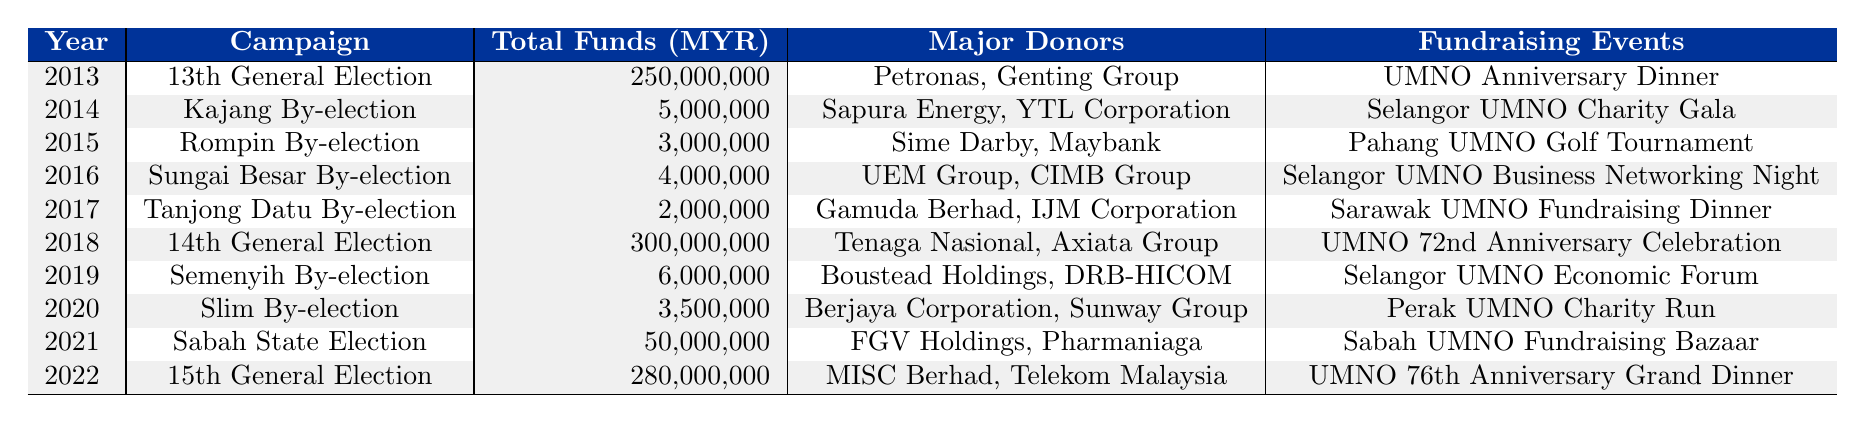What was the total amount raised in the 14th General Election? From the table, we see that in 2018, during the 14th General Election, the total funds raised were listed as 300,000,000 MYR.
Answer: 300,000,000 MYR Which campaign had the highest total funds raised? By comparing the values under "Total Funds Raised (MYR)," the campaigns for the 13th General Election and the 14th General Election both raised the highest amount at 300,000,000 MYR.
Answer: 13th and 14th General Elections How much more did the 13th General Election raise than the Slim By-election? For the 13th General Election, the total raised was 250,000,000 MYR, and for the Slim By-election, it was 3,500,000 MYR. The difference is 250,000,000 - 3,500,000 = 246,500,000 MYR.
Answer: 246,500,000 MYR Which year had the least amount raised, and how much was it? Scanning through the data, 2017 (Tanjong Datu By-election) had the least amount raised, which was 2,000,000 MYR.
Answer: 2017, 2,000,000 MYR What is the average amount raised per year for the years listed? The total funds raised across all campaigns amounts to 593,500,000 MYR, and there are 10 campaigns listed. Therefore, the average is 593,500,000 / 10 = 59,350,000 MYR.
Answer: 59,350,000 MYR Did the total funds raised in the 15th General Election exceed the total from the Slim By-election? The 15th General Election raised 280,000,000 MYR, while the Slim By-election raised 3,500,000 MYR. Since 280,000,000 is greater than 3,500,000, the statement is true.
Answer: Yes How much funding was raised from the by-elections in total? Adding the funds raised from each by-election: 5,000,000 (Kajang) + 3,000,000 (Rompin) + 4,000,000 (Sungai Besar) + 2,000,000 (Tanjong Datu) + 6,000,000 (Semenyih) + 3,500,000 (Slim) = 23,500,000 MYR in total.
Answer: 23,500,000 MYR Which major donor contributed to both the 14th General Election and the 13th General Election? By reviewing the "Major Donors," Tenaga Nasional and Axiata Group only appear in the 14th General Election, while Petronas and Genting Group are listed for the 13th. Since there are no overlapping major donors in the table for these two events, the answer is none.
Answer: None What were the total funds raised from campaigns held in even years over the past decade? Looking at the even years: 2014 (5,000,000), 2016 (4,000,000), 2018 (300,000,000), 2020 (3,500,000), and 2022 (280,000,000). Summing these gives 5,000,000 + 4,000,000 + 300,000,000 + 3,500,000 + 280,000,000 = 592,500,000 MYR.
Answer: 592,500,000 MYR How many fundraising events were there in total for all campaigns combined? By counting the "Fundraising Events" listed, there are 10 unique events, corresponding to each campaign listed in the table.
Answer: 10 